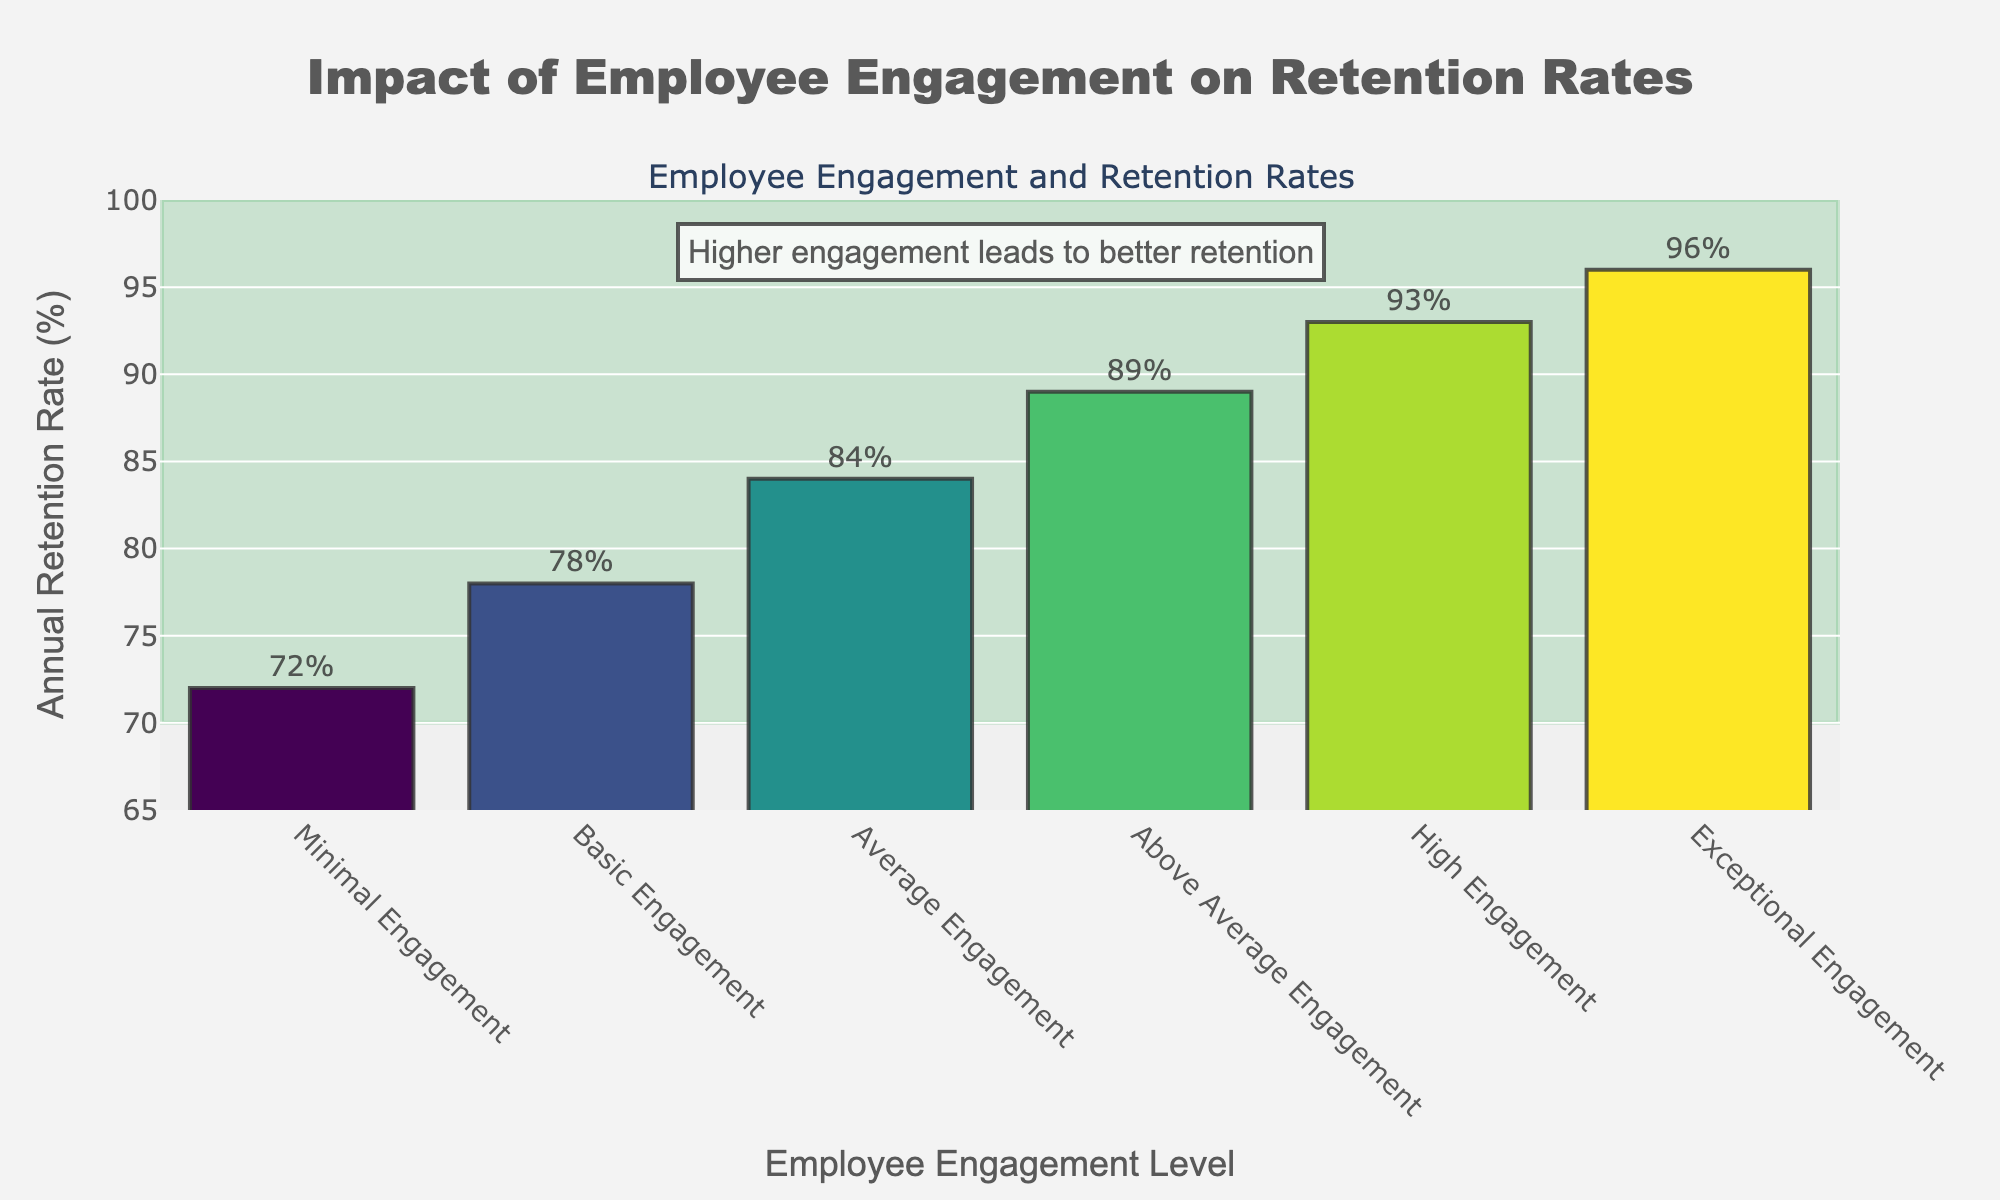What's the highest retention rate shown in the figure? The highest retention rate can be identified by looking for the tallest bar. The Exceptional Engagement level has the retention rate of 96%.
Answer: 96% Which engagement level has the lowest retention rate? The lowest retention rate is represented by the shortest bar. The Minimal Engagement level has a retention rate of 72%.
Answer: Minimal Engagement How much higher is the retention rate for Exceptional Engagement compared to Minimal Engagement? Subtract the retention rate of Minimal Engagement from that of Exceptional Engagement: 96% - 72% = 24%.
Answer: 24% What is the range of retention rates across different levels of employee engagement? The range is calculated by subtracting the minimum retention rate from the maximum retention rate: 96% - 72% = 24%.
Answer: 24% Which employee engagement level is associated with a retention rate of 84%? The retention rate of 84% corresponds to the Average Engagement level, as indicated by the respective bar's label.
Answer: Average Engagement Is the retention rate of High Engagement greater than Basic Engagement by more than 10 percentage points? Subtract the retention rate of Basic Engagement (78%) from that of High Engagement (93%): 93% - 78% = 15%. This difference is more than 10 percentage points.
Answer: Yes What is the median retention rate among the different levels of employee engagement? The retention rates in ascending order are: 72%, 78%, 84%, 89%, 93%, 96%. The median is the average of the middle two numbers: (84% + 89%) / 2 = 86.5%.
Answer: 86.5% Which two engagement levels have a retention rate difference closest to 7%? Calculate the differences between retention rates for each consecutive level: Basic and Minimal (78% - 72% = 6%), Average and Basic (84% - 78% = 6%), Above Average and Average (89% - 84% = 5%), High and Above Average (93% - 89% = 4%), Exceptional and High (96% - 93% = 3%). The pairs with differences closest to 7% are Minimal and Basic, and Basic and Average (both 6%).
Answer: Basic and Minimal, Basic and Average How does the retention rate change as the level of employee engagement increases? The retention rate increases consistently from 72% at Minimal Engagement to 96% at Exceptional Engagement, indicating a positive correlation between engagement and retention rates.
Answer: Increases 